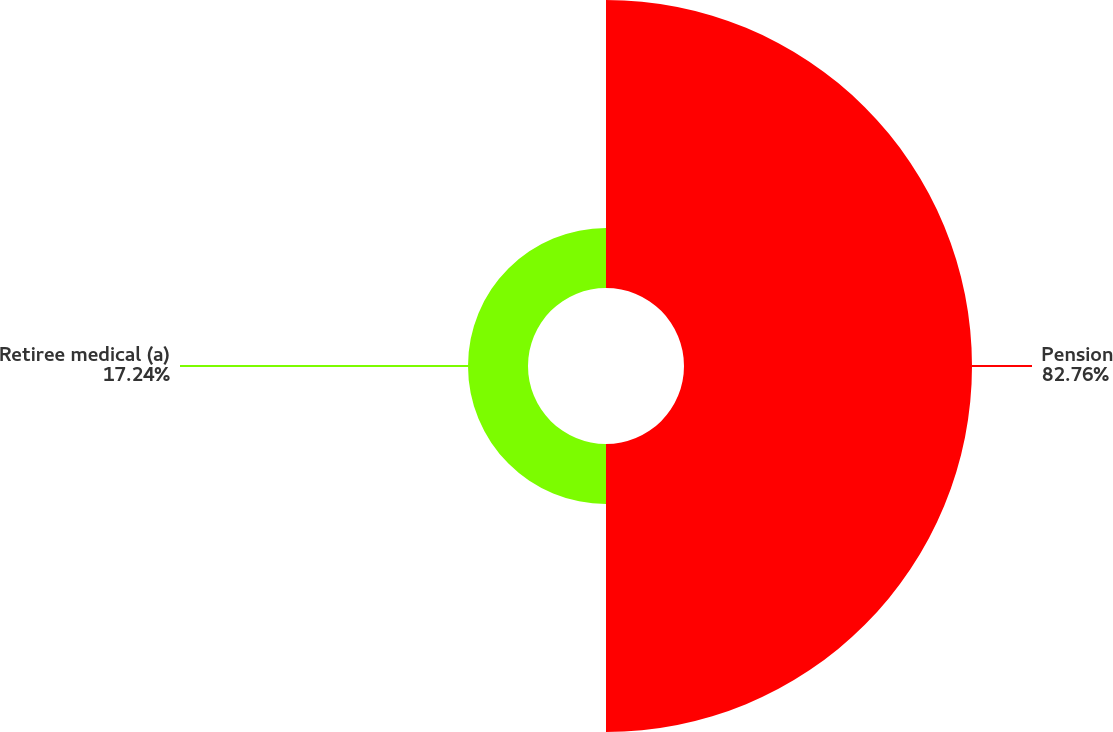<chart> <loc_0><loc_0><loc_500><loc_500><pie_chart><fcel>Pension<fcel>Retiree medical (a)<nl><fcel>82.76%<fcel>17.24%<nl></chart> 